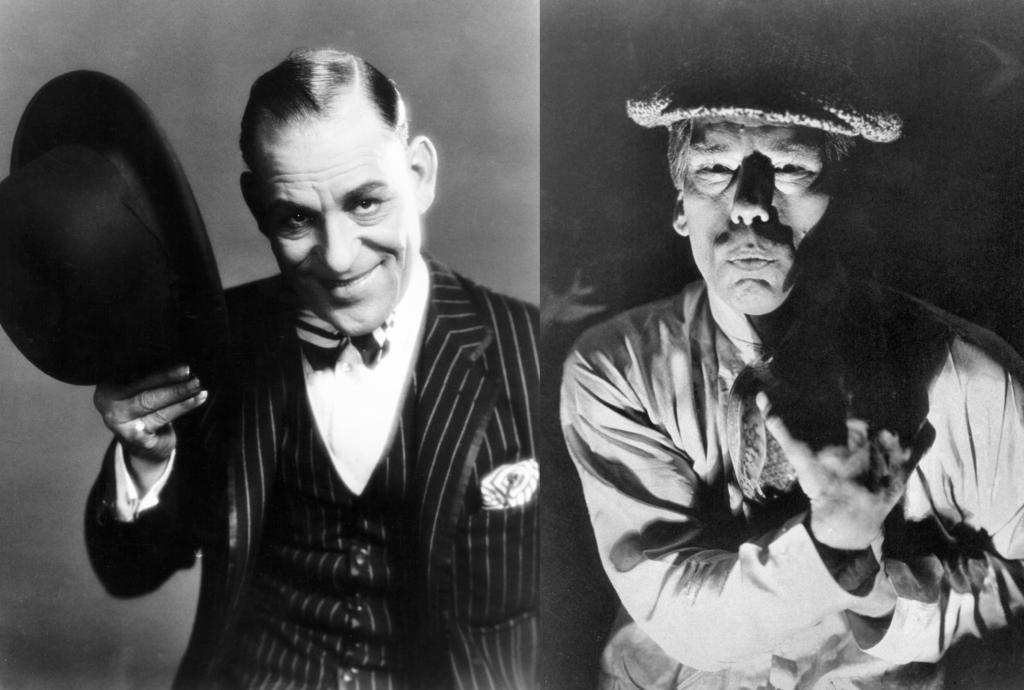Can you describe this image briefly? This black and white picture is collage of two different images. To the left there is a man standing. He is wearing suit. He is smiling. He is holding a hat in his hand. To the right there is a man standing. He is wearing a cap on his head. 